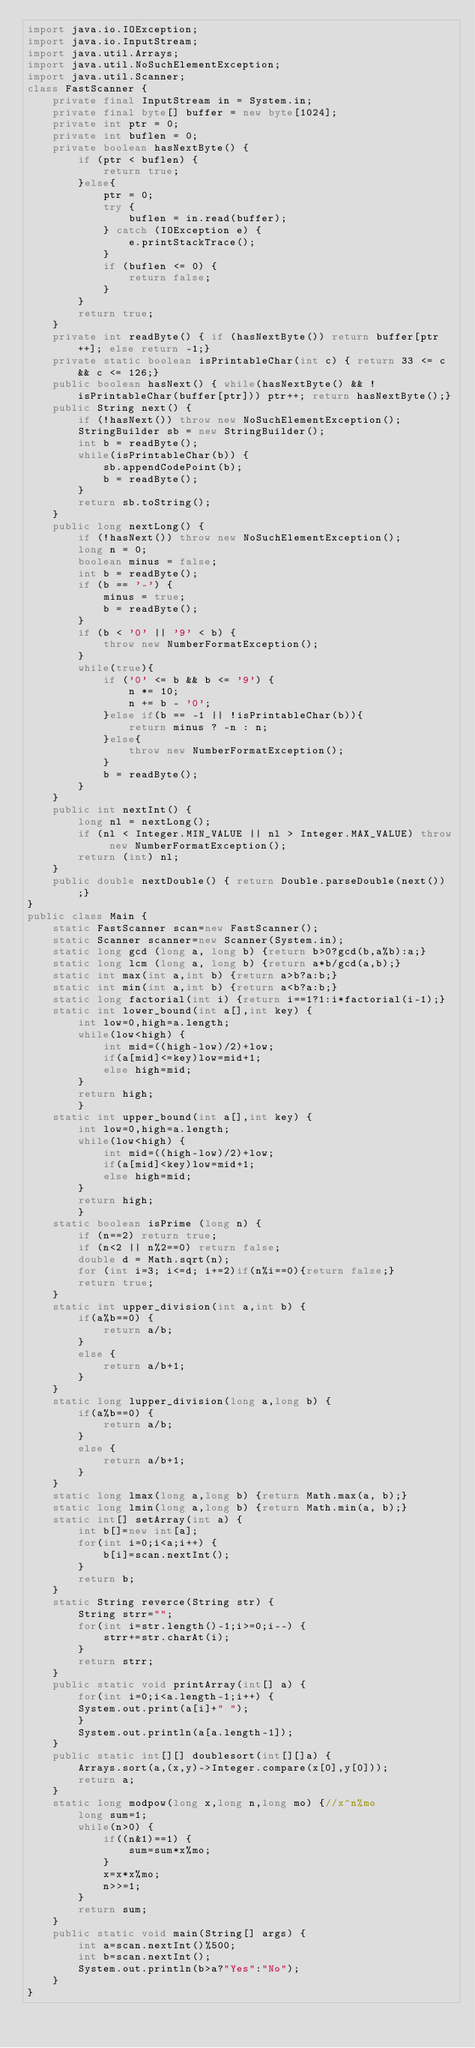Convert code to text. <code><loc_0><loc_0><loc_500><loc_500><_Java_>import java.io.IOException;
import java.io.InputStream;
import java.util.Arrays;
import java.util.NoSuchElementException;
import java.util.Scanner;
class FastScanner {
    private final InputStream in = System.in;
    private final byte[] buffer = new byte[1024];
    private int ptr = 0;
    private int buflen = 0;
    private boolean hasNextByte() {
        if (ptr < buflen) {
            return true;
        }else{
            ptr = 0;
            try {
                buflen = in.read(buffer);
            } catch (IOException e) {
                e.printStackTrace();
            }
            if (buflen <= 0) {
                return false;
            }
        }
        return true;
    }
    private int readByte() { if (hasNextByte()) return buffer[ptr++]; else return -1;}
    private static boolean isPrintableChar(int c) { return 33 <= c && c <= 126;}
    public boolean hasNext() { while(hasNextByte() && !isPrintableChar(buffer[ptr])) ptr++; return hasNextByte();}
    public String next() {
        if (!hasNext()) throw new NoSuchElementException();
        StringBuilder sb = new StringBuilder();
        int b = readByte();
        while(isPrintableChar(b)) {
            sb.appendCodePoint(b);
            b = readByte();
        }
        return sb.toString();
    }
    public long nextLong() {
        if (!hasNext()) throw new NoSuchElementException();
        long n = 0;
        boolean minus = false;
        int b = readByte();
        if (b == '-') {
            minus = true;
            b = readByte();
        }
        if (b < '0' || '9' < b) {
            throw new NumberFormatException();
        }
        while(true){
            if ('0' <= b && b <= '9') {
                n *= 10;
                n += b - '0';
            }else if(b == -1 || !isPrintableChar(b)){
                return minus ? -n : n;
            }else{
                throw new NumberFormatException();
            }
            b = readByte();
        }
    }
    public int nextInt() {
        long nl = nextLong();
        if (nl < Integer.MIN_VALUE || nl > Integer.MAX_VALUE) throw new NumberFormatException();
        return (int) nl;
    }
    public double nextDouble() { return Double.parseDouble(next());}
}
public class Main {
    static FastScanner scan=new FastScanner();
    static Scanner scanner=new Scanner(System.in);
    static long gcd (long a, long b) {return b>0?gcd(b,a%b):a;}
    static long lcm (long a, long b) {return a*b/gcd(a,b);}
    static int max(int a,int b) {return a>b?a:b;}
    static int min(int a,int b) {return a<b?a:b;}
    static long factorial(int i) {return i==1?1:i*factorial(i-1);}
    static int lower_bound(int a[],int key) {
        int low=0,high=a.length;
        while(low<high) {
            int mid=((high-low)/2)+low;
            if(a[mid]<=key)low=mid+1;
            else high=mid;
        }
        return high;
        }
    static int upper_bound(int a[],int key) {
        int low=0,high=a.length;
        while(low<high) {
            int mid=((high-low)/2)+low;
            if(a[mid]<key)low=mid+1;
            else high=mid;
        }
        return high;
        }
    static boolean isPrime (long n) {
        if (n==2) return true;
        if (n<2 || n%2==0) return false;
        double d = Math.sqrt(n);
        for (int i=3; i<=d; i+=2)if(n%i==0){return false;}
        return true;
    }
    static int upper_division(int a,int b) {
        if(a%b==0) {
            return a/b;
        }
        else {
            return a/b+1;
        }
    }
    static long lupper_division(long a,long b) {
        if(a%b==0) {
            return a/b;
        }
        else {
            return a/b+1;
        }
    }
    static long lmax(long a,long b) {return Math.max(a, b);}
    static long lmin(long a,long b) {return Math.min(a, b);}
    static int[] setArray(int a) {
        int b[]=new int[a];
        for(int i=0;i<a;i++) {
            b[i]=scan.nextInt();
        }
        return b;
    }
    static String reverce(String str) {
        String strr="";
        for(int i=str.length()-1;i>=0;i--) {
            strr+=str.charAt(i);
        }
        return strr;
    }
    public static void printArray(int[] a) {
        for(int i=0;i<a.length-1;i++) {
        System.out.print(a[i]+" ");
        }
        System.out.println(a[a.length-1]);
    }
    public static int[][] doublesort(int[][]a) {
        Arrays.sort(a,(x,y)->Integer.compare(x[0],y[0]));
        return a;
    }
    static long modpow(long x,long n,long mo) {//x^n%mo
        long sum=1;
        while(n>0) {
            if((n&1)==1) {
                sum=sum*x%mo;
            }
            x=x*x%mo;
            n>>=1;
        }
        return sum;
    }
    public static void main(String[] args) {
    	int a=scan.nextInt()%500;
    	int b=scan.nextInt();
    	System.out.println(b>a?"Yes":"No");
    }
}</code> 